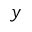<formula> <loc_0><loc_0><loc_500><loc_500>y</formula> 